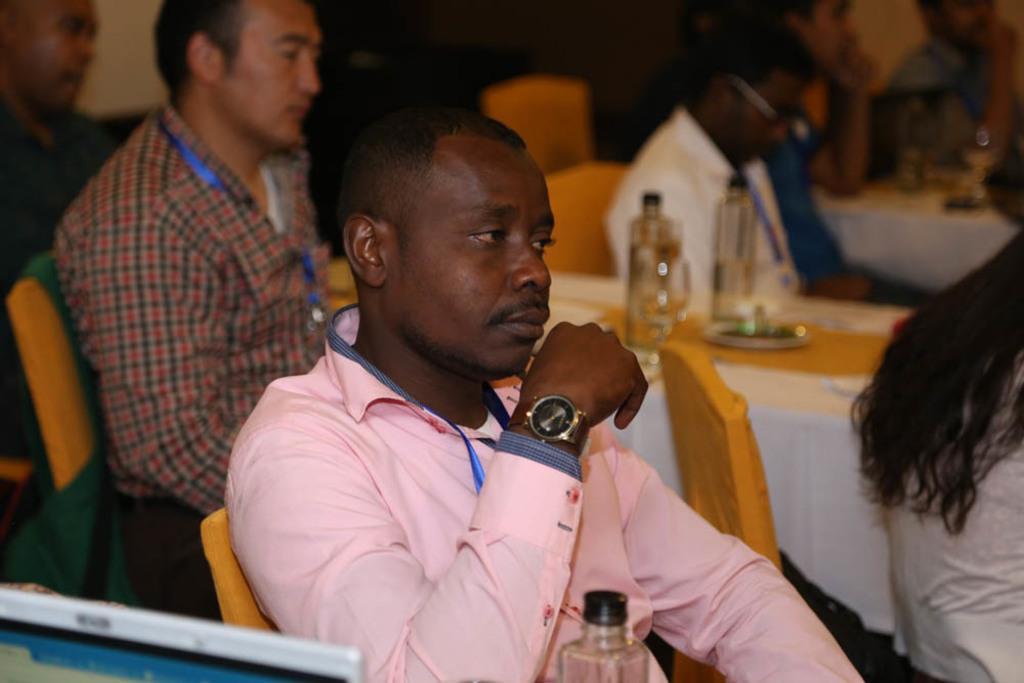Could you give a brief overview of what you see in this image? In this image i can see few persons sitting on chairs in front of a table. On the table i can see a plate and few bottles. The person in the pink dress is wearing a watch. 